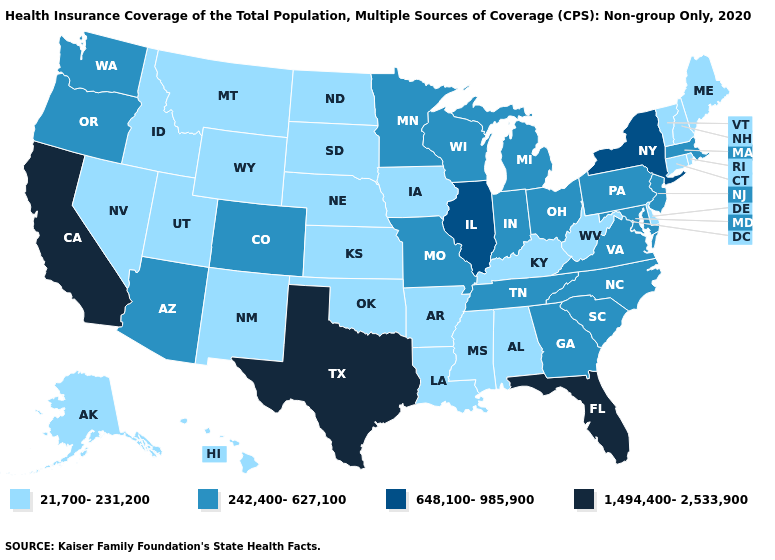What is the value of Vermont?
Be succinct. 21,700-231,200. What is the value of West Virginia?
Keep it brief. 21,700-231,200. What is the highest value in the USA?
Give a very brief answer. 1,494,400-2,533,900. Name the states that have a value in the range 1,494,400-2,533,900?
Be succinct. California, Florida, Texas. Does Pennsylvania have the lowest value in the Northeast?
Write a very short answer. No. What is the value of New Hampshire?
Short answer required. 21,700-231,200. Does Texas have the highest value in the South?
Keep it brief. Yes. Does Kentucky have the same value as Delaware?
Short answer required. Yes. What is the value of Iowa?
Keep it brief. 21,700-231,200. What is the value of Georgia?
Be succinct. 242,400-627,100. Which states have the lowest value in the USA?
Short answer required. Alabama, Alaska, Arkansas, Connecticut, Delaware, Hawaii, Idaho, Iowa, Kansas, Kentucky, Louisiana, Maine, Mississippi, Montana, Nebraska, Nevada, New Hampshire, New Mexico, North Dakota, Oklahoma, Rhode Island, South Dakota, Utah, Vermont, West Virginia, Wyoming. What is the value of Connecticut?
Quick response, please. 21,700-231,200. Does North Dakota have the highest value in the MidWest?
Answer briefly. No. Name the states that have a value in the range 21,700-231,200?
Quick response, please. Alabama, Alaska, Arkansas, Connecticut, Delaware, Hawaii, Idaho, Iowa, Kansas, Kentucky, Louisiana, Maine, Mississippi, Montana, Nebraska, Nevada, New Hampshire, New Mexico, North Dakota, Oklahoma, Rhode Island, South Dakota, Utah, Vermont, West Virginia, Wyoming. 